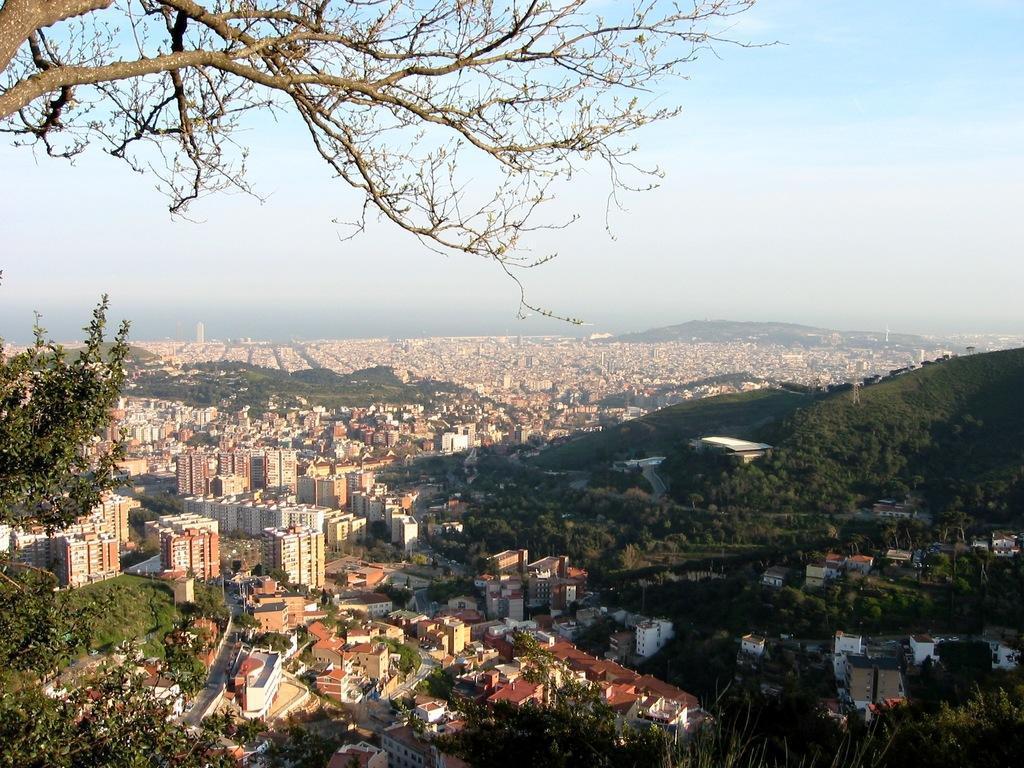Please provide a concise description of this image. In this image there are trees, buildings, mountains. At the top of the image there is sky. 